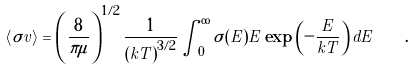<formula> <loc_0><loc_0><loc_500><loc_500>\left < \sigma v \right > = \left ( \frac { 8 } { \pi \mu } \right ) ^ { 1 / 2 } \frac { 1 } { \left ( k T \right ) ^ { 3 / 2 } } \int _ { 0 } ^ { \infty } \sigma ( E ) E \exp \left ( - \frac { E } { k T } \right ) d E \quad .</formula> 